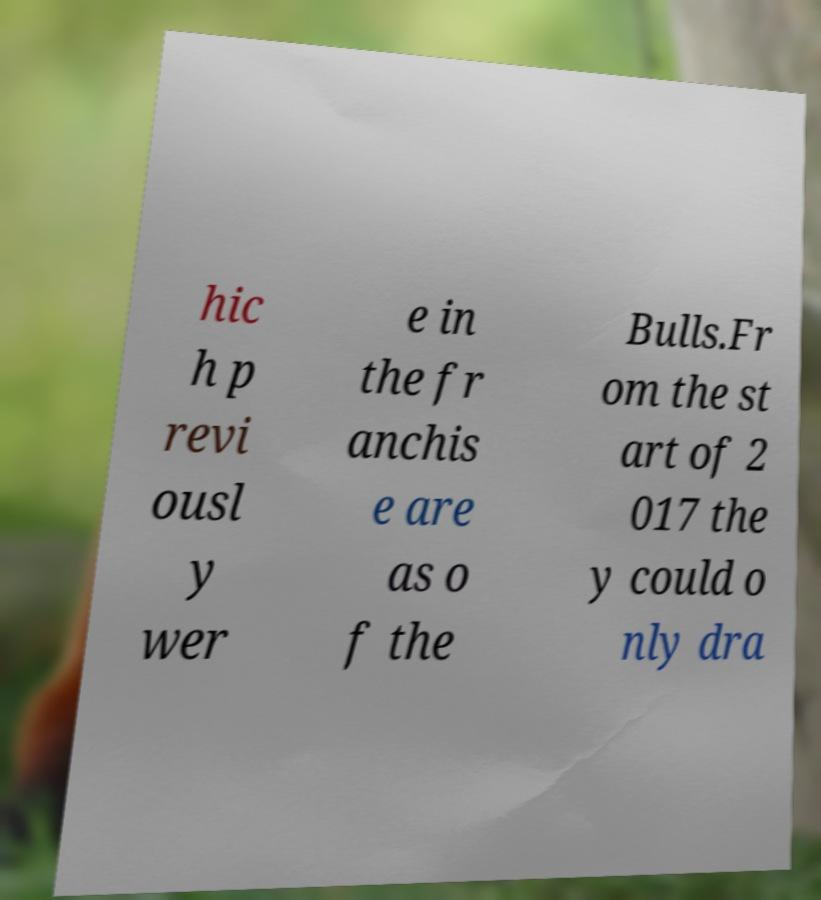What messages or text are displayed in this image? I need them in a readable, typed format. hic h p revi ousl y wer e in the fr anchis e are as o f the Bulls.Fr om the st art of 2 017 the y could o nly dra 